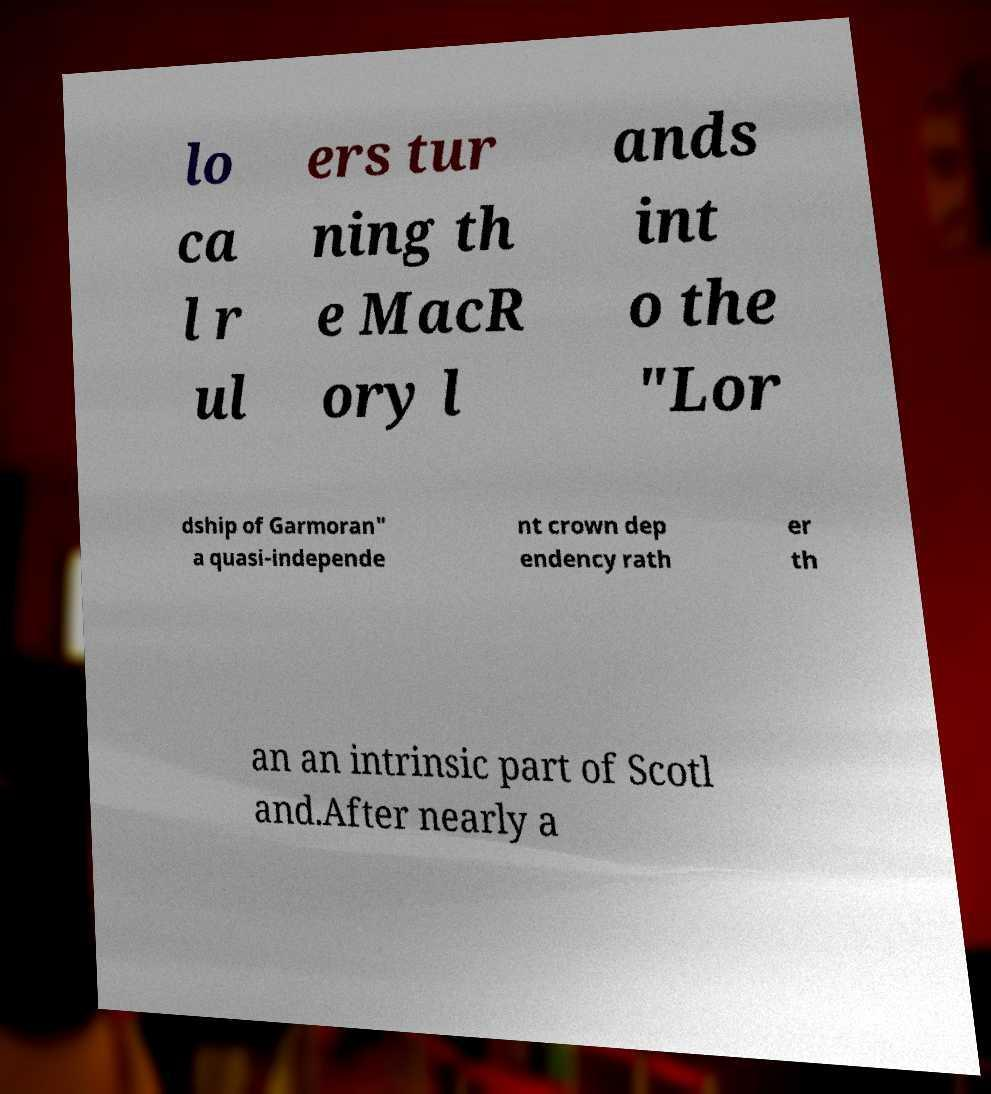There's text embedded in this image that I need extracted. Can you transcribe it verbatim? lo ca l r ul ers tur ning th e MacR ory l ands int o the "Lor dship of Garmoran" a quasi-independe nt crown dep endency rath er th an an intrinsic part of Scotl and.After nearly a 